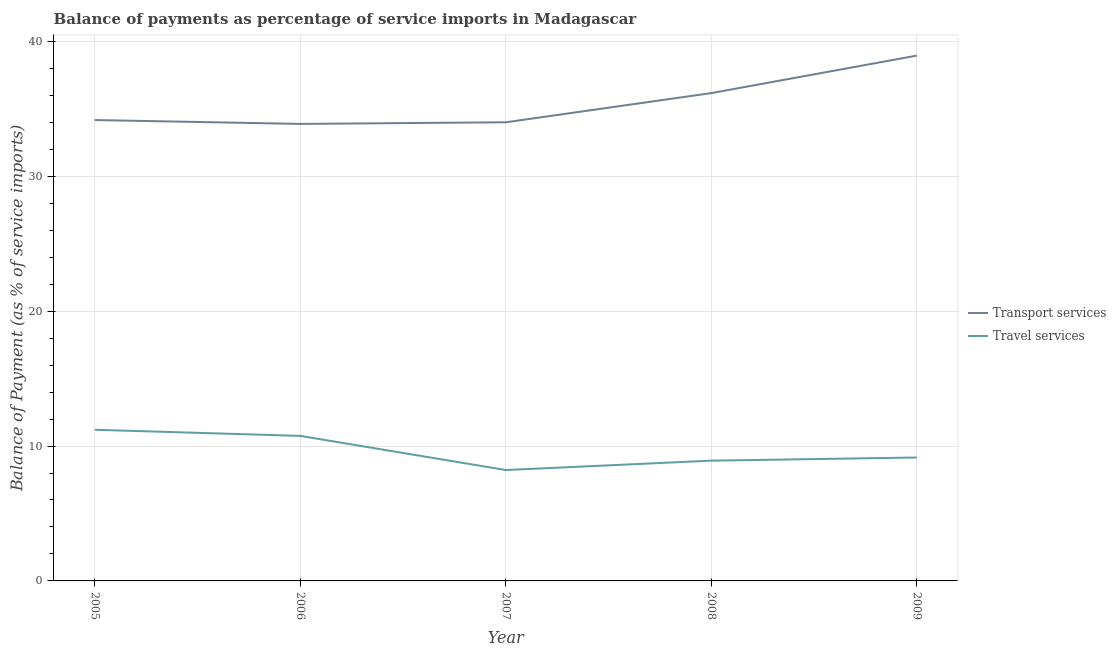How many different coloured lines are there?
Provide a succinct answer. 2. Is the number of lines equal to the number of legend labels?
Keep it short and to the point. Yes. What is the balance of payments of travel services in 2008?
Keep it short and to the point. 8.92. Across all years, what is the maximum balance of payments of transport services?
Provide a succinct answer. 38.94. Across all years, what is the minimum balance of payments of transport services?
Give a very brief answer. 33.88. In which year was the balance of payments of transport services minimum?
Ensure brevity in your answer.  2006. What is the total balance of payments of transport services in the graph?
Give a very brief answer. 177.15. What is the difference between the balance of payments of transport services in 2007 and that in 2009?
Make the answer very short. -4.94. What is the difference between the balance of payments of travel services in 2007 and the balance of payments of transport services in 2005?
Your answer should be very brief. -25.94. What is the average balance of payments of travel services per year?
Ensure brevity in your answer.  9.65. In the year 2008, what is the difference between the balance of payments of transport services and balance of payments of travel services?
Your answer should be compact. 27.25. What is the ratio of the balance of payments of travel services in 2006 to that in 2009?
Make the answer very short. 1.18. Is the difference between the balance of payments of travel services in 2005 and 2007 greater than the difference between the balance of payments of transport services in 2005 and 2007?
Provide a succinct answer. Yes. What is the difference between the highest and the second highest balance of payments of transport services?
Give a very brief answer. 2.78. What is the difference between the highest and the lowest balance of payments of travel services?
Make the answer very short. 2.98. Is the sum of the balance of payments of transport services in 2005 and 2008 greater than the maximum balance of payments of travel services across all years?
Your answer should be very brief. Yes. Does the balance of payments of transport services monotonically increase over the years?
Offer a very short reply. No. Is the balance of payments of travel services strictly less than the balance of payments of transport services over the years?
Ensure brevity in your answer.  Yes. How many lines are there?
Offer a terse response. 2. How many years are there in the graph?
Provide a short and direct response. 5. What is the difference between two consecutive major ticks on the Y-axis?
Provide a short and direct response. 10. Are the values on the major ticks of Y-axis written in scientific E-notation?
Your response must be concise. No. Does the graph contain any zero values?
Give a very brief answer. No. Where does the legend appear in the graph?
Your answer should be very brief. Center right. How many legend labels are there?
Your response must be concise. 2. How are the legend labels stacked?
Give a very brief answer. Vertical. What is the title of the graph?
Keep it short and to the point. Balance of payments as percentage of service imports in Madagascar. Does "National Visitors" appear as one of the legend labels in the graph?
Ensure brevity in your answer.  No. What is the label or title of the Y-axis?
Keep it short and to the point. Balance of Payment (as % of service imports). What is the Balance of Payment (as % of service imports) of Transport services in 2005?
Ensure brevity in your answer.  34.16. What is the Balance of Payment (as % of service imports) of Travel services in 2005?
Keep it short and to the point. 11.21. What is the Balance of Payment (as % of service imports) of Transport services in 2006?
Give a very brief answer. 33.88. What is the Balance of Payment (as % of service imports) in Travel services in 2006?
Offer a very short reply. 10.75. What is the Balance of Payment (as % of service imports) of Transport services in 2007?
Your response must be concise. 34. What is the Balance of Payment (as % of service imports) of Travel services in 2007?
Give a very brief answer. 8.22. What is the Balance of Payment (as % of service imports) in Transport services in 2008?
Give a very brief answer. 36.16. What is the Balance of Payment (as % of service imports) of Travel services in 2008?
Give a very brief answer. 8.92. What is the Balance of Payment (as % of service imports) in Transport services in 2009?
Offer a terse response. 38.94. What is the Balance of Payment (as % of service imports) of Travel services in 2009?
Offer a very short reply. 9.15. Across all years, what is the maximum Balance of Payment (as % of service imports) of Transport services?
Give a very brief answer. 38.94. Across all years, what is the maximum Balance of Payment (as % of service imports) of Travel services?
Your answer should be very brief. 11.21. Across all years, what is the minimum Balance of Payment (as % of service imports) in Transport services?
Give a very brief answer. 33.88. Across all years, what is the minimum Balance of Payment (as % of service imports) of Travel services?
Your answer should be compact. 8.22. What is the total Balance of Payment (as % of service imports) in Transport services in the graph?
Offer a terse response. 177.15. What is the total Balance of Payment (as % of service imports) in Travel services in the graph?
Your answer should be compact. 48.24. What is the difference between the Balance of Payment (as % of service imports) in Transport services in 2005 and that in 2006?
Give a very brief answer. 0.29. What is the difference between the Balance of Payment (as % of service imports) in Travel services in 2005 and that in 2006?
Provide a short and direct response. 0.45. What is the difference between the Balance of Payment (as % of service imports) of Transport services in 2005 and that in 2007?
Your answer should be very brief. 0.17. What is the difference between the Balance of Payment (as % of service imports) of Travel services in 2005 and that in 2007?
Your answer should be very brief. 2.98. What is the difference between the Balance of Payment (as % of service imports) in Transport services in 2005 and that in 2008?
Keep it short and to the point. -2. What is the difference between the Balance of Payment (as % of service imports) in Travel services in 2005 and that in 2008?
Ensure brevity in your answer.  2.29. What is the difference between the Balance of Payment (as % of service imports) of Transport services in 2005 and that in 2009?
Keep it short and to the point. -4.78. What is the difference between the Balance of Payment (as % of service imports) in Travel services in 2005 and that in 2009?
Keep it short and to the point. 2.06. What is the difference between the Balance of Payment (as % of service imports) in Transport services in 2006 and that in 2007?
Provide a short and direct response. -0.12. What is the difference between the Balance of Payment (as % of service imports) in Travel services in 2006 and that in 2007?
Your response must be concise. 2.53. What is the difference between the Balance of Payment (as % of service imports) of Transport services in 2006 and that in 2008?
Offer a very short reply. -2.28. What is the difference between the Balance of Payment (as % of service imports) in Travel services in 2006 and that in 2008?
Offer a very short reply. 1.84. What is the difference between the Balance of Payment (as % of service imports) in Transport services in 2006 and that in 2009?
Ensure brevity in your answer.  -5.06. What is the difference between the Balance of Payment (as % of service imports) of Travel services in 2006 and that in 2009?
Offer a very short reply. 1.6. What is the difference between the Balance of Payment (as % of service imports) of Transport services in 2007 and that in 2008?
Offer a very short reply. -2.16. What is the difference between the Balance of Payment (as % of service imports) in Travel services in 2007 and that in 2008?
Provide a succinct answer. -0.69. What is the difference between the Balance of Payment (as % of service imports) in Transport services in 2007 and that in 2009?
Provide a succinct answer. -4.94. What is the difference between the Balance of Payment (as % of service imports) in Travel services in 2007 and that in 2009?
Provide a short and direct response. -0.93. What is the difference between the Balance of Payment (as % of service imports) of Transport services in 2008 and that in 2009?
Keep it short and to the point. -2.78. What is the difference between the Balance of Payment (as % of service imports) in Travel services in 2008 and that in 2009?
Give a very brief answer. -0.23. What is the difference between the Balance of Payment (as % of service imports) in Transport services in 2005 and the Balance of Payment (as % of service imports) in Travel services in 2006?
Your answer should be very brief. 23.41. What is the difference between the Balance of Payment (as % of service imports) of Transport services in 2005 and the Balance of Payment (as % of service imports) of Travel services in 2007?
Offer a very short reply. 25.94. What is the difference between the Balance of Payment (as % of service imports) in Transport services in 2005 and the Balance of Payment (as % of service imports) in Travel services in 2008?
Your answer should be very brief. 25.25. What is the difference between the Balance of Payment (as % of service imports) in Transport services in 2005 and the Balance of Payment (as % of service imports) in Travel services in 2009?
Your response must be concise. 25.02. What is the difference between the Balance of Payment (as % of service imports) in Transport services in 2006 and the Balance of Payment (as % of service imports) in Travel services in 2007?
Your answer should be very brief. 25.66. What is the difference between the Balance of Payment (as % of service imports) of Transport services in 2006 and the Balance of Payment (as % of service imports) of Travel services in 2008?
Keep it short and to the point. 24.96. What is the difference between the Balance of Payment (as % of service imports) of Transport services in 2006 and the Balance of Payment (as % of service imports) of Travel services in 2009?
Give a very brief answer. 24.73. What is the difference between the Balance of Payment (as % of service imports) in Transport services in 2007 and the Balance of Payment (as % of service imports) in Travel services in 2008?
Make the answer very short. 25.08. What is the difference between the Balance of Payment (as % of service imports) in Transport services in 2007 and the Balance of Payment (as % of service imports) in Travel services in 2009?
Provide a succinct answer. 24.85. What is the difference between the Balance of Payment (as % of service imports) in Transport services in 2008 and the Balance of Payment (as % of service imports) in Travel services in 2009?
Your response must be concise. 27.01. What is the average Balance of Payment (as % of service imports) of Transport services per year?
Your answer should be compact. 35.43. What is the average Balance of Payment (as % of service imports) of Travel services per year?
Offer a very short reply. 9.65. In the year 2005, what is the difference between the Balance of Payment (as % of service imports) of Transport services and Balance of Payment (as % of service imports) of Travel services?
Your answer should be compact. 22.96. In the year 2006, what is the difference between the Balance of Payment (as % of service imports) in Transport services and Balance of Payment (as % of service imports) in Travel services?
Offer a terse response. 23.13. In the year 2007, what is the difference between the Balance of Payment (as % of service imports) in Transport services and Balance of Payment (as % of service imports) in Travel services?
Provide a succinct answer. 25.78. In the year 2008, what is the difference between the Balance of Payment (as % of service imports) of Transport services and Balance of Payment (as % of service imports) of Travel services?
Offer a terse response. 27.25. In the year 2009, what is the difference between the Balance of Payment (as % of service imports) in Transport services and Balance of Payment (as % of service imports) in Travel services?
Give a very brief answer. 29.79. What is the ratio of the Balance of Payment (as % of service imports) of Transport services in 2005 to that in 2006?
Provide a succinct answer. 1.01. What is the ratio of the Balance of Payment (as % of service imports) of Travel services in 2005 to that in 2006?
Keep it short and to the point. 1.04. What is the ratio of the Balance of Payment (as % of service imports) of Travel services in 2005 to that in 2007?
Your answer should be compact. 1.36. What is the ratio of the Balance of Payment (as % of service imports) in Transport services in 2005 to that in 2008?
Your answer should be compact. 0.94. What is the ratio of the Balance of Payment (as % of service imports) in Travel services in 2005 to that in 2008?
Make the answer very short. 1.26. What is the ratio of the Balance of Payment (as % of service imports) in Transport services in 2005 to that in 2009?
Provide a succinct answer. 0.88. What is the ratio of the Balance of Payment (as % of service imports) of Travel services in 2005 to that in 2009?
Make the answer very short. 1.22. What is the ratio of the Balance of Payment (as % of service imports) of Transport services in 2006 to that in 2007?
Give a very brief answer. 1. What is the ratio of the Balance of Payment (as % of service imports) of Travel services in 2006 to that in 2007?
Your answer should be very brief. 1.31. What is the ratio of the Balance of Payment (as % of service imports) of Transport services in 2006 to that in 2008?
Make the answer very short. 0.94. What is the ratio of the Balance of Payment (as % of service imports) in Travel services in 2006 to that in 2008?
Provide a short and direct response. 1.21. What is the ratio of the Balance of Payment (as % of service imports) in Transport services in 2006 to that in 2009?
Your answer should be very brief. 0.87. What is the ratio of the Balance of Payment (as % of service imports) of Travel services in 2006 to that in 2009?
Offer a terse response. 1.18. What is the ratio of the Balance of Payment (as % of service imports) of Transport services in 2007 to that in 2008?
Ensure brevity in your answer.  0.94. What is the ratio of the Balance of Payment (as % of service imports) of Travel services in 2007 to that in 2008?
Your response must be concise. 0.92. What is the ratio of the Balance of Payment (as % of service imports) in Transport services in 2007 to that in 2009?
Make the answer very short. 0.87. What is the ratio of the Balance of Payment (as % of service imports) in Travel services in 2007 to that in 2009?
Your answer should be compact. 0.9. What is the ratio of the Balance of Payment (as % of service imports) of Travel services in 2008 to that in 2009?
Make the answer very short. 0.97. What is the difference between the highest and the second highest Balance of Payment (as % of service imports) in Transport services?
Make the answer very short. 2.78. What is the difference between the highest and the second highest Balance of Payment (as % of service imports) in Travel services?
Give a very brief answer. 0.45. What is the difference between the highest and the lowest Balance of Payment (as % of service imports) in Transport services?
Ensure brevity in your answer.  5.06. What is the difference between the highest and the lowest Balance of Payment (as % of service imports) of Travel services?
Your response must be concise. 2.98. 